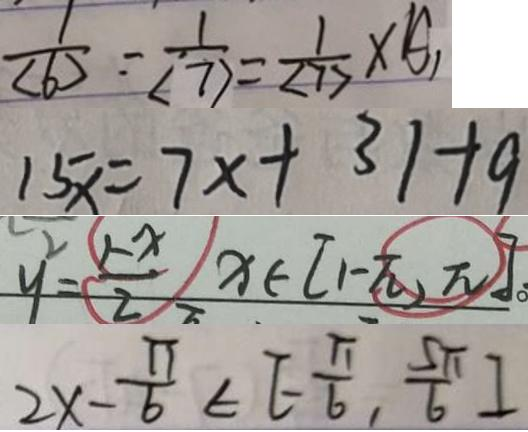<formula> <loc_0><loc_0><loc_500><loc_500>\frac { 1 } { ( b ) } = \frac { 1 } { ( 7 ) } = \frac { 1 } { ( 7 ) } \times A 
 1 5 x = 7 x + 3 1 + 9 
 y ^ { 2 } = \frac { 1 - x } { 2 } ) x \in [ 1 - \pi , \pi ] 
 2 x - \frac { \pi } { 6 } \in [ - \frac { \pi } { 6 } , \frac { 5 \pi } { 6 } ]</formula> 